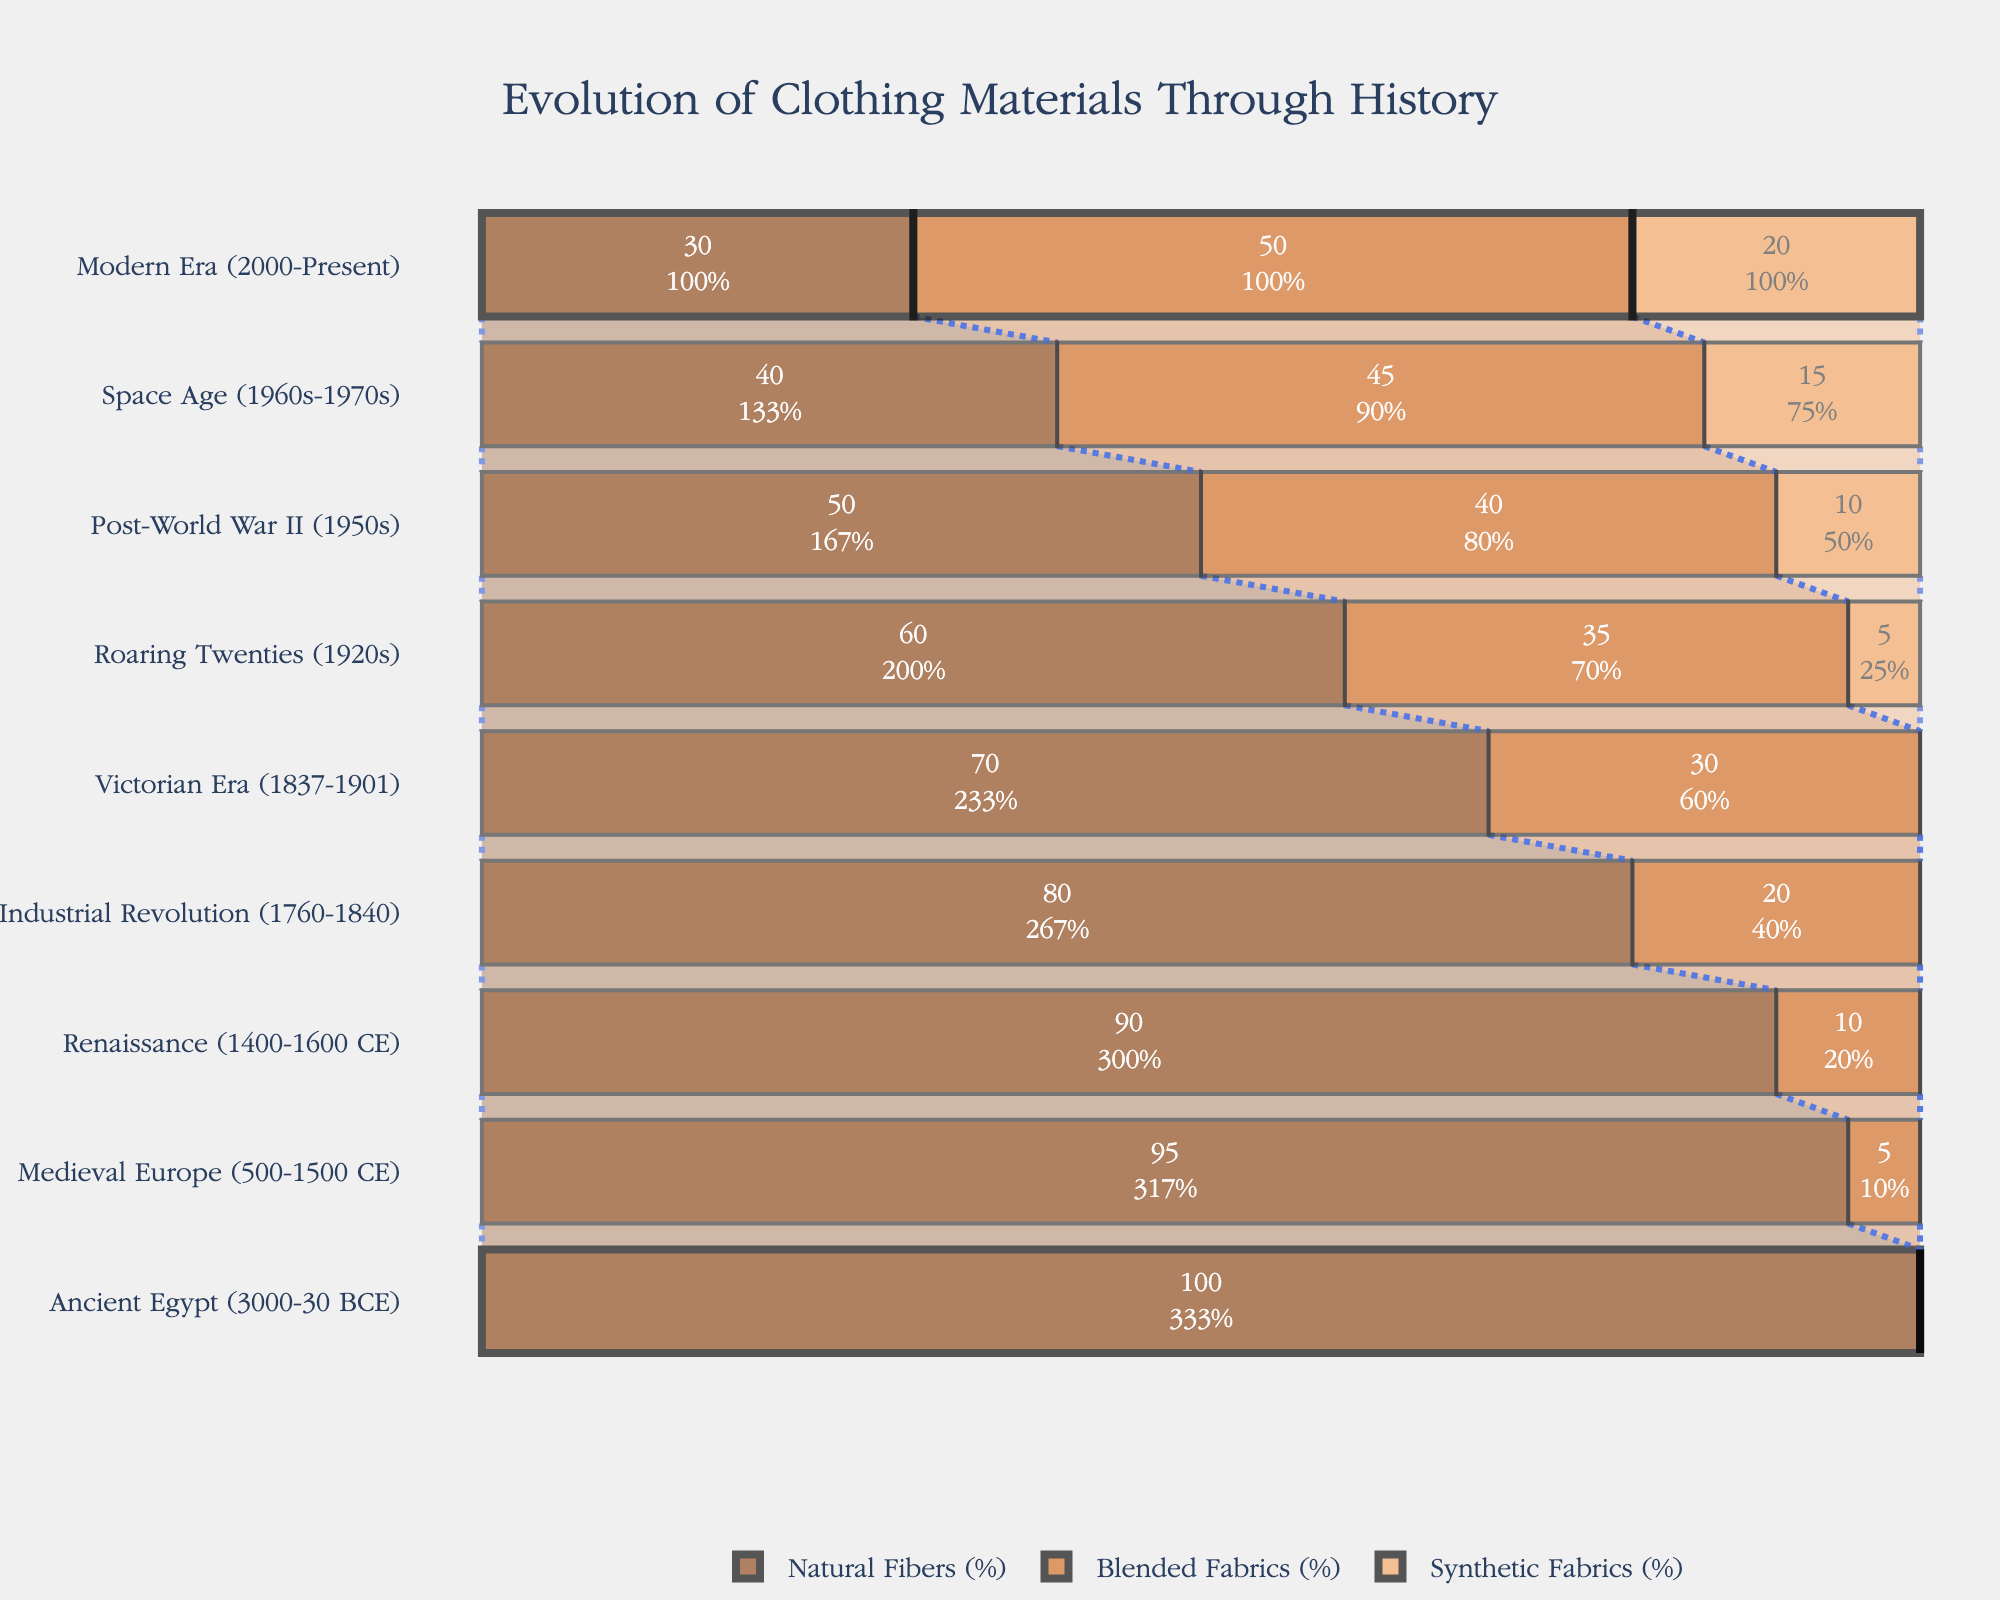What is the title of the funnel chart? The title of the chart is located at the top center and summarizes the purpose of the chart.
Answer: Evolution of Clothing Materials Through History How many historical periods are depicted in the chart? The periods are listed along the y-axis. Count the entries to determine the number of periods.
Answer: 9 Which historical period shows 100% usage of natural fibers? Check the section in the chart where the Natural Fibers bar reaches 100%.
Answer: Ancient Egypt (3000-30 BCE) By how much did the percentage of natural fibers decrease from the Industrial Revolution to the Victorian Era? Compare the values for Natural Fibers in these two periods and calculate the difference.
Answer: 10% During which period did synthetic fabrics first appear in the chart? Identify the earliest period where the Synthetic Fabrics bar is present.
Answer: Roaring Twenties (1920s) What percentage of blended fabrics was used in the Post-World War II period? Locate the Blended Fabrics bar for the Post-World War II period and read the percentage.
Answer: 40% How much did the percentage of blended fabrics increase from the Medieval Europe to the Renaissance? Subtract the percentage value of Blended Fabrics in Medieval Europe from that in the Renaissance.
Answer: 5% In the Space Age period, what is the combined percentage of synthetic and blended fabrics? Add the percentages of Synthetic Fabrics and Blended Fabrics in the Space Age period.
Answer: 60% Which period shows the highest percentage of blended fabrics? Identify the period where the Blended Fabrics bar is the longest.
Answer: Modern Era (2000-Present) How did the composition of clothing materials change from the Roaring Twenties to the Post-World War II period? Compare the values for each type of fabric between these two periods and discuss their changes.
Answer: Natural Fibers decreased from 60% to 50%, Blended Fabrics increased from 35% to 40%, Synthetic Fabrics increased from 5% to 10% 